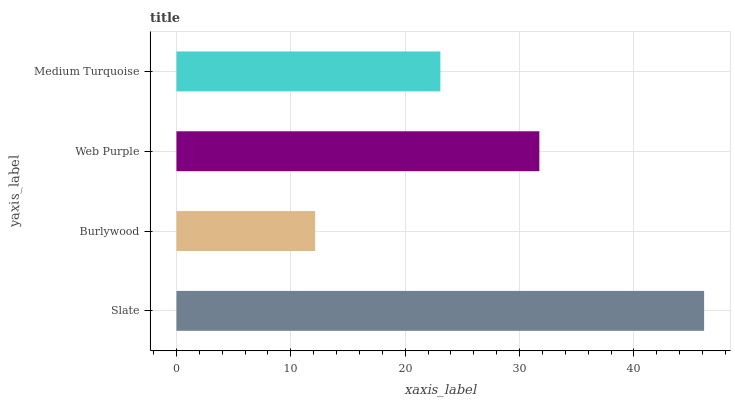Is Burlywood the minimum?
Answer yes or no. Yes. Is Slate the maximum?
Answer yes or no. Yes. Is Web Purple the minimum?
Answer yes or no. No. Is Web Purple the maximum?
Answer yes or no. No. Is Web Purple greater than Burlywood?
Answer yes or no. Yes. Is Burlywood less than Web Purple?
Answer yes or no. Yes. Is Burlywood greater than Web Purple?
Answer yes or no. No. Is Web Purple less than Burlywood?
Answer yes or no. No. Is Web Purple the high median?
Answer yes or no. Yes. Is Medium Turquoise the low median?
Answer yes or no. Yes. Is Medium Turquoise the high median?
Answer yes or no. No. Is Web Purple the low median?
Answer yes or no. No. 